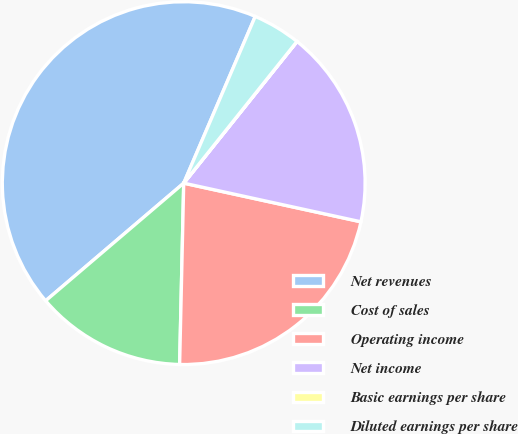<chart> <loc_0><loc_0><loc_500><loc_500><pie_chart><fcel>Net revenues<fcel>Cost of sales<fcel>Operating income<fcel>Net income<fcel>Basic earnings per share<fcel>Diluted earnings per share<nl><fcel>42.68%<fcel>13.41%<fcel>21.94%<fcel>17.68%<fcel>0.01%<fcel>4.28%<nl></chart> 